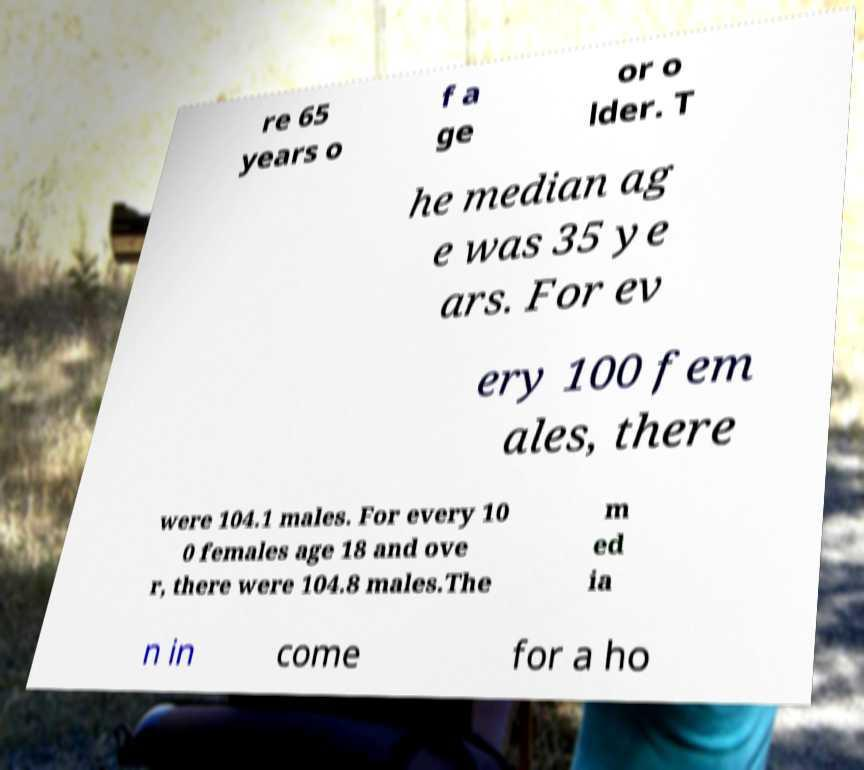Please read and relay the text visible in this image. What does it say? re 65 years o f a ge or o lder. T he median ag e was 35 ye ars. For ev ery 100 fem ales, there were 104.1 males. For every 10 0 females age 18 and ove r, there were 104.8 males.The m ed ia n in come for a ho 